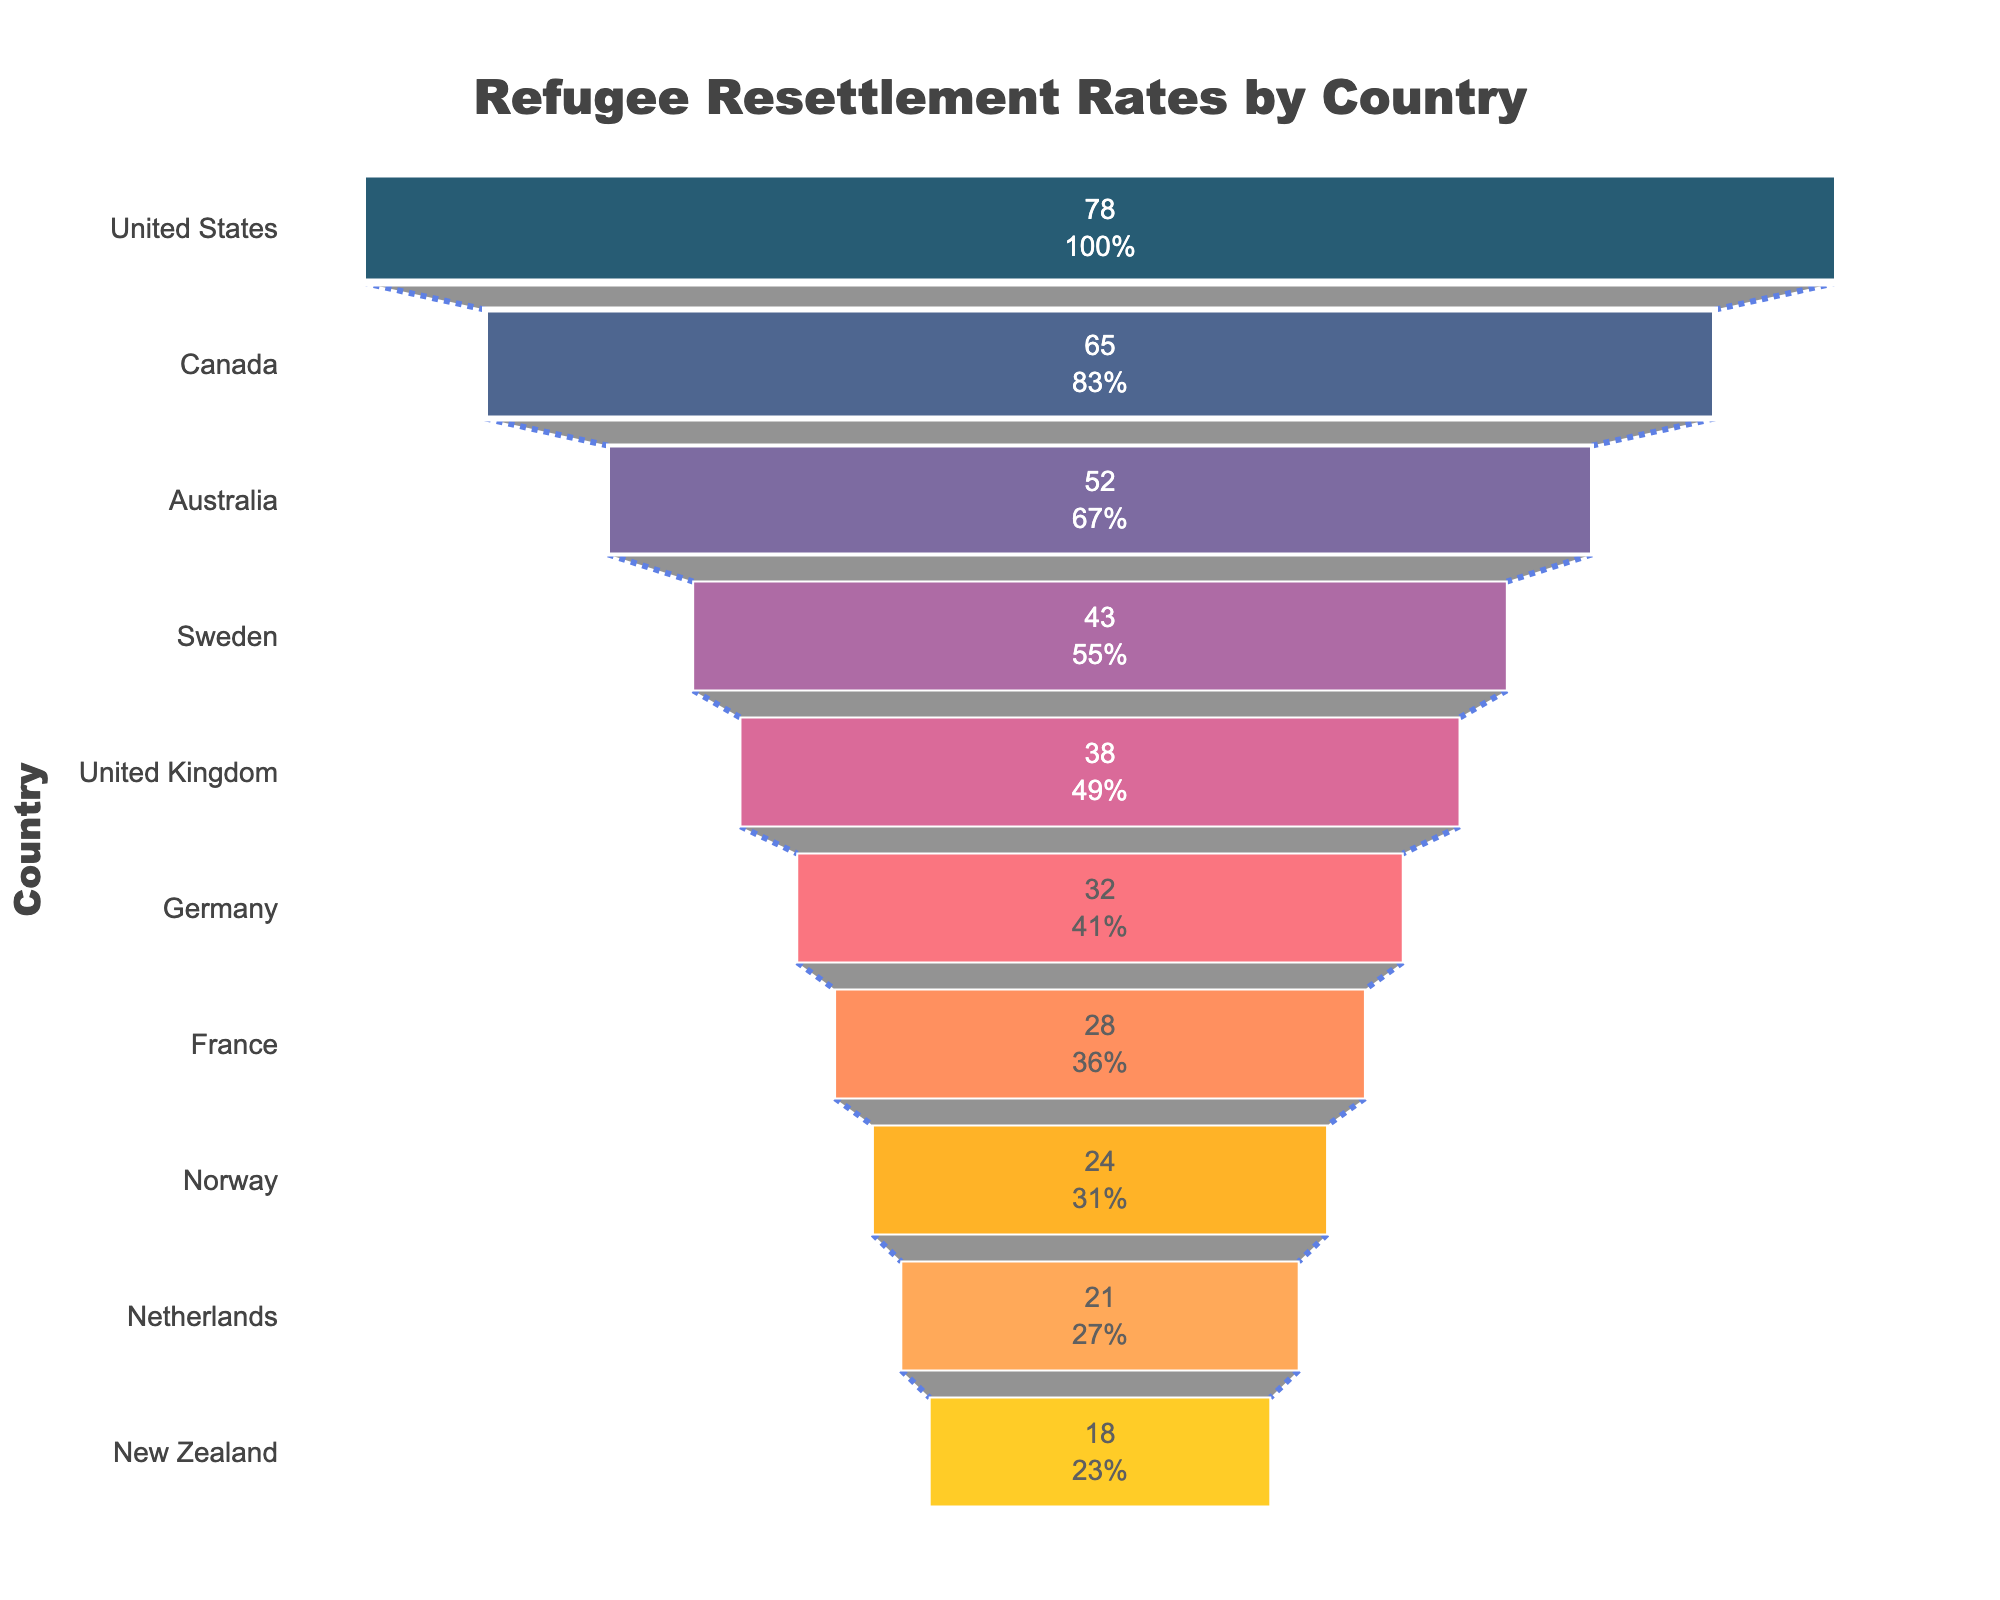How many countries are represented in the funnel chart? To find the total number of countries, count the distinct entries in the 'Country' column of the funnel chart.
Answer: 10 Which country has the highest refugee resettlement rate? The funnel chart is sorted by the resettlement rate in descending order, so the country at the top of the chart has the highest rate.
Answer: United States What is the resettlement rate for Germany? Locate Germany in the funnel chart and refer to its corresponding resettlement rate.
Answer: 32 How much higher is the resettlement rate in Canada compared to France? Find the resettlement rates for Canada (65) and France (28), then subtract the French rate from the Canadian rate: 65 - 28.
Answer: 37 Which country has a lower resettlement rate, Norway or the Netherlands? Compare the resettlement rates for Norway (24) and the Netherlands (21). Observer that Netherlands has the lower rate.
Answer: Netherlands What is the combined resettlement rate for the top three countries? Sum the resettlement rates of the top three countries: United States (78), Canada (65), and Australia (52): 78 + 65 + 52.
Answer: 195 What percentage of the total resettled refugees are in the United States? The total resettled rate is the sum of the resettlement rates for all countries: 78 + 65 + 52 + 43 + 38 + 32 + 28 + 24 + 21 + 18 = 399. Now, compute the percentage for the United States' rate: (78 / 399) * 100.
Answer: 19.55% Is the United Kingdom's resettlement rate higher or lower than the median rate? Order the rates and find the median: (18, 21, 24, 28, 32, 38, 43, 52, 65, 78). The median is the average of the 5th and 6th values: (32 + 38) / 2 = 35. Since the UK's rate is 38, it is higher.
Answer: Higher Which country marks the transition from higher to lower half in the chart? The median lies between the 5th and 6th points in the sorted list: Germany (32) is the 5th and the United Kingdom (38) is the 6th. The transition point is marked by Germany’s resettlement rate.
Answer: Germany 